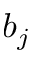<formula> <loc_0><loc_0><loc_500><loc_500>b _ { j }</formula> 